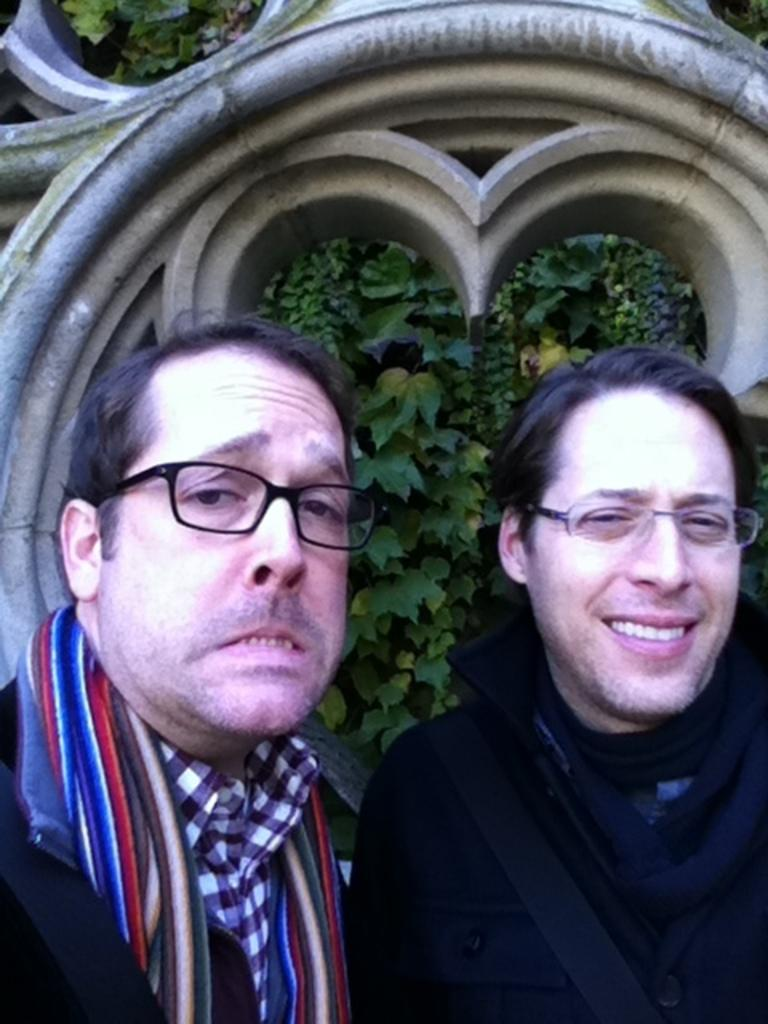How many people are in the image? There are two people in the image. What are the people wearing? Both people are wearing spectacles. What can be seen in the background of the image? There is a designed stone and leaves in the background of the image. What degree does the sister of the person in the image have? There is no mention of a sister or degree in the image, so this information cannot be determined. 